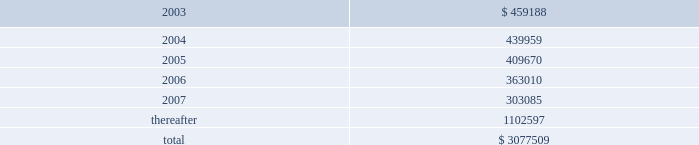American tower corporation and subsidiaries notes to consolidated financial statements 2014 ( continued ) customer leases 2014the company 2019s lease agreements with its customers vary depending upon the industry .
Television and radio broadcasters prefer long-term leases , while wireless communications providers favor leases in the range of five to ten years .
Most leases contain renewal options .
Escalation clauses present in operating leases , excluding those tied to cpi , are straight-lined over the term of the lease .
Future minimum rental receipts expected from customers under noncancelable operating lease agreements in effect at december 31 , 2002 are as follows ( in thousands ) : year ending december 31 .
Acquisition commitments 2014as of december 31 , 2002 , the company was party to an agreement relating to the acquisition of tower assets from a third party for an estimated aggregate purchase price of approximately $ 74.0 million .
The company may pursue the acquisitions of other properties and businesses in new and existing locations , although there are no definitive material agreements with respect thereto .
Build-to-suit agreements 2014as of december 31 , 2002 , the company was party to various arrangements relating to the construction of tower sites under existing build-to-suit agreements .
Under the terms of the agreements , the company is obligated to construct up to 1000 towers over a five year period which includes 650 towers in mexico and 350 towers in brazil over the next three years .
The company is in the process of renegotiating several of these agreements to reduce its overall commitment ; however , there can be no assurance that it will be successful in doing so .
Atc separation 2014the company was a wholly owned subsidiary of american radio systems corporation ( american radio ) until consummation of the spin-off of the company from american radio on june 4 , 1998 ( the atc separation ) .
On june 4 , 1998 , the merger of american radio and a subsidiary of cbs corporation ( cbs ) was consummated .
As a result of the merger , all of the outstanding shares of the company 2019s common stock owned by american radio were distributed or reserved for distribution to american radio stockholders , and the company ceased to be a subsidiary of , or to be otherwise affiliated with , american radio .
Furthermore , from that day forward the company began operating as an independent publicly traded company .
In connection with the atc separation , the company agreed to reimburse cbs for any tax liabilities incurred by american radio as a result of the transaction .
Upon completion of the final american radio tax returns , the amount of these tax liabilities was determined and paid by the company .
The company continues to be obligated under a tax indemnification agreement with cbs , however , until june 30 , 2003 , subject to the extension of federal and applicable state statutes of limitations .
The company is currently aware that the internal revenue service ( irs ) is in the process of auditing certain tax returns filed by cbs and its predecessors , including those that relate to american radio and the atc separation transaction .
In the event that the irs imposes additional tax liabilities on american radio relating to the atc separation , the company would be obligated to reimburse cbs for such liabilities .
The company cannot currently anticipate or estimate the potential additional tax liabilities , if any , that may be imposed by the irs , however , such amounts could be material to the company 2019s consolidated financial position and results of operations .
The company is not aware of any material obligations relating to this tax indemnity as of december 31 , 2002 .
Accordingly , no amounts have been provided for in the consolidated financial statements relating to this indemnification. .
What portion of future minimum rental receipts is expected to be collected within the next 12 months? 
Computations: (459188 / 3077509)
Answer: 0.14921. 